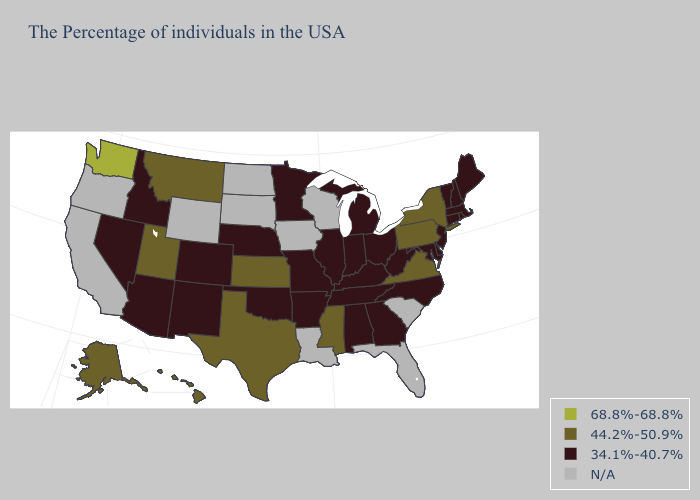Name the states that have a value in the range 68.8%-68.8%?
Answer briefly. Washington. Among the states that border Florida , which have the highest value?
Be succinct. Georgia, Alabama. Name the states that have a value in the range 34.1%-40.7%?
Keep it brief. Maine, Massachusetts, Rhode Island, New Hampshire, Vermont, Connecticut, New Jersey, Delaware, Maryland, North Carolina, West Virginia, Ohio, Georgia, Michigan, Kentucky, Indiana, Alabama, Tennessee, Illinois, Missouri, Arkansas, Minnesota, Nebraska, Oklahoma, Colorado, New Mexico, Arizona, Idaho, Nevada. What is the highest value in the USA?
Write a very short answer. 68.8%-68.8%. Name the states that have a value in the range N/A?
Answer briefly. South Carolina, Florida, Wisconsin, Louisiana, Iowa, South Dakota, North Dakota, Wyoming, California, Oregon. What is the highest value in the Northeast ?
Be succinct. 44.2%-50.9%. Which states have the highest value in the USA?
Be succinct. Washington. What is the value of Mississippi?
Write a very short answer. 44.2%-50.9%. Does the map have missing data?
Answer briefly. Yes. Among the states that border Colorado , which have the highest value?
Quick response, please. Kansas, Utah. Does the map have missing data?
Be succinct. Yes. Does New Mexico have the lowest value in the USA?
Concise answer only. Yes. 